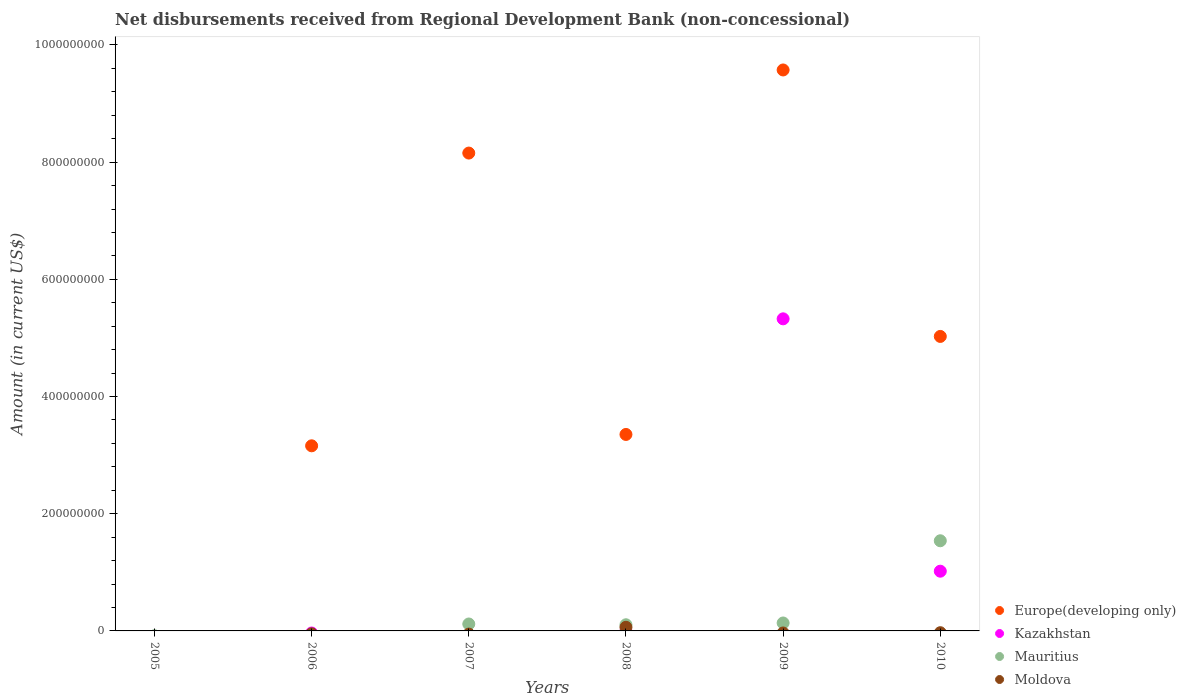Across all years, what is the maximum amount of disbursements received from Regional Development Bank in Mauritius?
Keep it short and to the point. 1.54e+08. Across all years, what is the minimum amount of disbursements received from Regional Development Bank in Moldova?
Provide a succinct answer. 0. What is the total amount of disbursements received from Regional Development Bank in Europe(developing only) in the graph?
Provide a short and direct response. 2.93e+09. What is the difference between the amount of disbursements received from Regional Development Bank in Mauritius in 2008 and that in 2009?
Provide a succinct answer. -3.05e+06. What is the average amount of disbursements received from Regional Development Bank in Moldova per year?
Your answer should be compact. 1.03e+06. What is the ratio of the amount of disbursements received from Regional Development Bank in Europe(developing only) in 2006 to that in 2009?
Offer a very short reply. 0.33. What is the difference between the highest and the lowest amount of disbursements received from Regional Development Bank in Kazakhstan?
Offer a terse response. 5.33e+08. In how many years, is the amount of disbursements received from Regional Development Bank in Kazakhstan greater than the average amount of disbursements received from Regional Development Bank in Kazakhstan taken over all years?
Provide a short and direct response. 1. Is the amount of disbursements received from Regional Development Bank in Moldova strictly greater than the amount of disbursements received from Regional Development Bank in Mauritius over the years?
Your answer should be very brief. No. How many years are there in the graph?
Give a very brief answer. 6. What is the difference between two consecutive major ticks on the Y-axis?
Keep it short and to the point. 2.00e+08. Does the graph contain grids?
Make the answer very short. No. What is the title of the graph?
Offer a very short reply. Net disbursements received from Regional Development Bank (non-concessional). What is the label or title of the X-axis?
Give a very brief answer. Years. What is the Amount (in current US$) in Mauritius in 2005?
Make the answer very short. 0. What is the Amount (in current US$) of Europe(developing only) in 2006?
Provide a succinct answer. 3.16e+08. What is the Amount (in current US$) in Mauritius in 2006?
Keep it short and to the point. 0. What is the Amount (in current US$) in Moldova in 2006?
Your answer should be very brief. 0. What is the Amount (in current US$) of Europe(developing only) in 2007?
Offer a terse response. 8.16e+08. What is the Amount (in current US$) of Kazakhstan in 2007?
Your answer should be compact. 0. What is the Amount (in current US$) in Mauritius in 2007?
Keep it short and to the point. 1.18e+07. What is the Amount (in current US$) in Europe(developing only) in 2008?
Provide a short and direct response. 3.35e+08. What is the Amount (in current US$) of Mauritius in 2008?
Make the answer very short. 1.05e+07. What is the Amount (in current US$) of Moldova in 2008?
Offer a terse response. 6.18e+06. What is the Amount (in current US$) in Europe(developing only) in 2009?
Provide a succinct answer. 9.57e+08. What is the Amount (in current US$) in Kazakhstan in 2009?
Provide a succinct answer. 5.33e+08. What is the Amount (in current US$) in Mauritius in 2009?
Offer a very short reply. 1.36e+07. What is the Amount (in current US$) of Moldova in 2009?
Offer a very short reply. 0. What is the Amount (in current US$) in Europe(developing only) in 2010?
Offer a very short reply. 5.03e+08. What is the Amount (in current US$) in Kazakhstan in 2010?
Provide a short and direct response. 1.02e+08. What is the Amount (in current US$) of Mauritius in 2010?
Give a very brief answer. 1.54e+08. What is the Amount (in current US$) in Moldova in 2010?
Your answer should be compact. 0. Across all years, what is the maximum Amount (in current US$) in Europe(developing only)?
Give a very brief answer. 9.57e+08. Across all years, what is the maximum Amount (in current US$) in Kazakhstan?
Ensure brevity in your answer.  5.33e+08. Across all years, what is the maximum Amount (in current US$) in Mauritius?
Offer a very short reply. 1.54e+08. Across all years, what is the maximum Amount (in current US$) in Moldova?
Offer a terse response. 6.18e+06. Across all years, what is the minimum Amount (in current US$) of Europe(developing only)?
Offer a very short reply. 0. Across all years, what is the minimum Amount (in current US$) in Moldova?
Your answer should be very brief. 0. What is the total Amount (in current US$) in Europe(developing only) in the graph?
Give a very brief answer. 2.93e+09. What is the total Amount (in current US$) in Kazakhstan in the graph?
Your response must be concise. 6.35e+08. What is the total Amount (in current US$) of Mauritius in the graph?
Offer a terse response. 1.90e+08. What is the total Amount (in current US$) in Moldova in the graph?
Provide a succinct answer. 6.18e+06. What is the difference between the Amount (in current US$) in Europe(developing only) in 2006 and that in 2007?
Offer a very short reply. -5.00e+08. What is the difference between the Amount (in current US$) in Europe(developing only) in 2006 and that in 2008?
Keep it short and to the point. -1.94e+07. What is the difference between the Amount (in current US$) in Europe(developing only) in 2006 and that in 2009?
Your answer should be very brief. -6.41e+08. What is the difference between the Amount (in current US$) in Europe(developing only) in 2006 and that in 2010?
Provide a succinct answer. -1.87e+08. What is the difference between the Amount (in current US$) in Europe(developing only) in 2007 and that in 2008?
Keep it short and to the point. 4.80e+08. What is the difference between the Amount (in current US$) of Mauritius in 2007 and that in 2008?
Provide a succinct answer. 1.32e+06. What is the difference between the Amount (in current US$) in Europe(developing only) in 2007 and that in 2009?
Offer a very short reply. -1.42e+08. What is the difference between the Amount (in current US$) of Mauritius in 2007 and that in 2009?
Give a very brief answer. -1.73e+06. What is the difference between the Amount (in current US$) in Europe(developing only) in 2007 and that in 2010?
Make the answer very short. 3.13e+08. What is the difference between the Amount (in current US$) of Mauritius in 2007 and that in 2010?
Your response must be concise. -1.42e+08. What is the difference between the Amount (in current US$) of Europe(developing only) in 2008 and that in 2009?
Make the answer very short. -6.22e+08. What is the difference between the Amount (in current US$) of Mauritius in 2008 and that in 2009?
Offer a very short reply. -3.05e+06. What is the difference between the Amount (in current US$) in Europe(developing only) in 2008 and that in 2010?
Offer a terse response. -1.67e+08. What is the difference between the Amount (in current US$) of Mauritius in 2008 and that in 2010?
Keep it short and to the point. -1.43e+08. What is the difference between the Amount (in current US$) of Europe(developing only) in 2009 and that in 2010?
Keep it short and to the point. 4.55e+08. What is the difference between the Amount (in current US$) in Kazakhstan in 2009 and that in 2010?
Your response must be concise. 4.31e+08. What is the difference between the Amount (in current US$) of Mauritius in 2009 and that in 2010?
Provide a short and direct response. -1.40e+08. What is the difference between the Amount (in current US$) in Europe(developing only) in 2006 and the Amount (in current US$) in Mauritius in 2007?
Make the answer very short. 3.04e+08. What is the difference between the Amount (in current US$) of Europe(developing only) in 2006 and the Amount (in current US$) of Mauritius in 2008?
Your response must be concise. 3.05e+08. What is the difference between the Amount (in current US$) of Europe(developing only) in 2006 and the Amount (in current US$) of Moldova in 2008?
Provide a short and direct response. 3.10e+08. What is the difference between the Amount (in current US$) in Europe(developing only) in 2006 and the Amount (in current US$) in Kazakhstan in 2009?
Offer a very short reply. -2.17e+08. What is the difference between the Amount (in current US$) in Europe(developing only) in 2006 and the Amount (in current US$) in Mauritius in 2009?
Make the answer very short. 3.02e+08. What is the difference between the Amount (in current US$) of Europe(developing only) in 2006 and the Amount (in current US$) of Kazakhstan in 2010?
Offer a terse response. 2.14e+08. What is the difference between the Amount (in current US$) of Europe(developing only) in 2006 and the Amount (in current US$) of Mauritius in 2010?
Ensure brevity in your answer.  1.62e+08. What is the difference between the Amount (in current US$) in Europe(developing only) in 2007 and the Amount (in current US$) in Mauritius in 2008?
Your response must be concise. 8.05e+08. What is the difference between the Amount (in current US$) of Europe(developing only) in 2007 and the Amount (in current US$) of Moldova in 2008?
Provide a succinct answer. 8.09e+08. What is the difference between the Amount (in current US$) in Mauritius in 2007 and the Amount (in current US$) in Moldova in 2008?
Offer a very short reply. 5.64e+06. What is the difference between the Amount (in current US$) of Europe(developing only) in 2007 and the Amount (in current US$) of Kazakhstan in 2009?
Make the answer very short. 2.83e+08. What is the difference between the Amount (in current US$) in Europe(developing only) in 2007 and the Amount (in current US$) in Mauritius in 2009?
Keep it short and to the point. 8.02e+08. What is the difference between the Amount (in current US$) in Europe(developing only) in 2007 and the Amount (in current US$) in Kazakhstan in 2010?
Give a very brief answer. 7.14e+08. What is the difference between the Amount (in current US$) in Europe(developing only) in 2007 and the Amount (in current US$) in Mauritius in 2010?
Your response must be concise. 6.62e+08. What is the difference between the Amount (in current US$) of Europe(developing only) in 2008 and the Amount (in current US$) of Kazakhstan in 2009?
Make the answer very short. -1.97e+08. What is the difference between the Amount (in current US$) of Europe(developing only) in 2008 and the Amount (in current US$) of Mauritius in 2009?
Keep it short and to the point. 3.22e+08. What is the difference between the Amount (in current US$) of Europe(developing only) in 2008 and the Amount (in current US$) of Kazakhstan in 2010?
Give a very brief answer. 2.33e+08. What is the difference between the Amount (in current US$) in Europe(developing only) in 2008 and the Amount (in current US$) in Mauritius in 2010?
Offer a very short reply. 1.81e+08. What is the difference between the Amount (in current US$) in Europe(developing only) in 2009 and the Amount (in current US$) in Kazakhstan in 2010?
Make the answer very short. 8.55e+08. What is the difference between the Amount (in current US$) of Europe(developing only) in 2009 and the Amount (in current US$) of Mauritius in 2010?
Your response must be concise. 8.04e+08. What is the difference between the Amount (in current US$) in Kazakhstan in 2009 and the Amount (in current US$) in Mauritius in 2010?
Your answer should be very brief. 3.79e+08. What is the average Amount (in current US$) in Europe(developing only) per year?
Make the answer very short. 4.88e+08. What is the average Amount (in current US$) of Kazakhstan per year?
Provide a succinct answer. 1.06e+08. What is the average Amount (in current US$) of Mauritius per year?
Your response must be concise. 3.16e+07. What is the average Amount (in current US$) in Moldova per year?
Offer a terse response. 1.03e+06. In the year 2007, what is the difference between the Amount (in current US$) in Europe(developing only) and Amount (in current US$) in Mauritius?
Give a very brief answer. 8.04e+08. In the year 2008, what is the difference between the Amount (in current US$) of Europe(developing only) and Amount (in current US$) of Mauritius?
Provide a short and direct response. 3.25e+08. In the year 2008, what is the difference between the Amount (in current US$) in Europe(developing only) and Amount (in current US$) in Moldova?
Your answer should be compact. 3.29e+08. In the year 2008, what is the difference between the Amount (in current US$) of Mauritius and Amount (in current US$) of Moldova?
Offer a very short reply. 4.32e+06. In the year 2009, what is the difference between the Amount (in current US$) in Europe(developing only) and Amount (in current US$) in Kazakhstan?
Provide a short and direct response. 4.25e+08. In the year 2009, what is the difference between the Amount (in current US$) of Europe(developing only) and Amount (in current US$) of Mauritius?
Your answer should be compact. 9.44e+08. In the year 2009, what is the difference between the Amount (in current US$) of Kazakhstan and Amount (in current US$) of Mauritius?
Your answer should be compact. 5.19e+08. In the year 2010, what is the difference between the Amount (in current US$) of Europe(developing only) and Amount (in current US$) of Kazakhstan?
Provide a succinct answer. 4.01e+08. In the year 2010, what is the difference between the Amount (in current US$) in Europe(developing only) and Amount (in current US$) in Mauritius?
Offer a terse response. 3.49e+08. In the year 2010, what is the difference between the Amount (in current US$) in Kazakhstan and Amount (in current US$) in Mauritius?
Your answer should be compact. -5.19e+07. What is the ratio of the Amount (in current US$) of Europe(developing only) in 2006 to that in 2007?
Keep it short and to the point. 0.39. What is the ratio of the Amount (in current US$) in Europe(developing only) in 2006 to that in 2008?
Your answer should be very brief. 0.94. What is the ratio of the Amount (in current US$) of Europe(developing only) in 2006 to that in 2009?
Your answer should be very brief. 0.33. What is the ratio of the Amount (in current US$) of Europe(developing only) in 2006 to that in 2010?
Your response must be concise. 0.63. What is the ratio of the Amount (in current US$) of Europe(developing only) in 2007 to that in 2008?
Ensure brevity in your answer.  2.43. What is the ratio of the Amount (in current US$) of Mauritius in 2007 to that in 2008?
Your response must be concise. 1.13. What is the ratio of the Amount (in current US$) of Europe(developing only) in 2007 to that in 2009?
Your answer should be compact. 0.85. What is the ratio of the Amount (in current US$) in Mauritius in 2007 to that in 2009?
Offer a terse response. 0.87. What is the ratio of the Amount (in current US$) in Europe(developing only) in 2007 to that in 2010?
Keep it short and to the point. 1.62. What is the ratio of the Amount (in current US$) in Mauritius in 2007 to that in 2010?
Provide a short and direct response. 0.08. What is the ratio of the Amount (in current US$) of Europe(developing only) in 2008 to that in 2009?
Make the answer very short. 0.35. What is the ratio of the Amount (in current US$) in Mauritius in 2008 to that in 2009?
Offer a terse response. 0.78. What is the ratio of the Amount (in current US$) of Europe(developing only) in 2008 to that in 2010?
Give a very brief answer. 0.67. What is the ratio of the Amount (in current US$) of Mauritius in 2008 to that in 2010?
Your answer should be very brief. 0.07. What is the ratio of the Amount (in current US$) in Europe(developing only) in 2009 to that in 2010?
Keep it short and to the point. 1.9. What is the ratio of the Amount (in current US$) of Kazakhstan in 2009 to that in 2010?
Offer a terse response. 5.23. What is the ratio of the Amount (in current US$) in Mauritius in 2009 to that in 2010?
Offer a very short reply. 0.09. What is the difference between the highest and the second highest Amount (in current US$) of Europe(developing only)?
Your response must be concise. 1.42e+08. What is the difference between the highest and the second highest Amount (in current US$) in Mauritius?
Your answer should be compact. 1.40e+08. What is the difference between the highest and the lowest Amount (in current US$) of Europe(developing only)?
Your answer should be very brief. 9.57e+08. What is the difference between the highest and the lowest Amount (in current US$) of Kazakhstan?
Offer a very short reply. 5.33e+08. What is the difference between the highest and the lowest Amount (in current US$) in Mauritius?
Provide a short and direct response. 1.54e+08. What is the difference between the highest and the lowest Amount (in current US$) of Moldova?
Provide a short and direct response. 6.18e+06. 